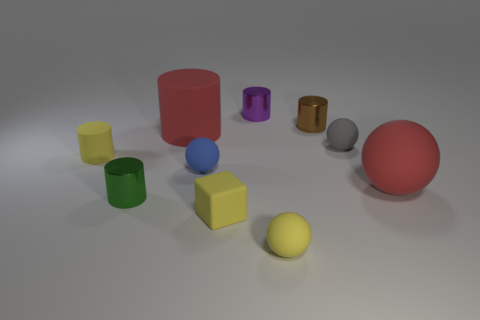Subtract all yellow cylinders. How many cylinders are left? 4 Subtract 2 spheres. How many spheres are left? 2 Subtract all red matte cylinders. How many cylinders are left? 4 Subtract all blue cylinders. Subtract all green blocks. How many cylinders are left? 5 Subtract all spheres. How many objects are left? 6 Add 5 tiny yellow cylinders. How many tiny yellow cylinders are left? 6 Add 4 tiny rubber spheres. How many tiny rubber spheres exist? 7 Subtract 1 yellow cubes. How many objects are left? 9 Subtract all blocks. Subtract all tiny yellow rubber cylinders. How many objects are left? 8 